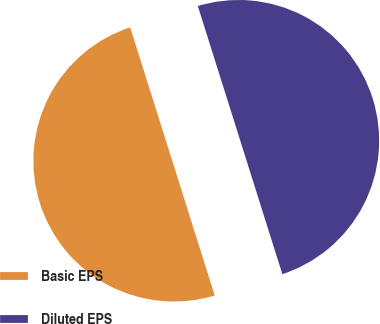Convert chart. <chart><loc_0><loc_0><loc_500><loc_500><pie_chart><fcel>Basic EPS<fcel>Diluted EPS<nl><fcel>50.0%<fcel>50.0%<nl></chart> 